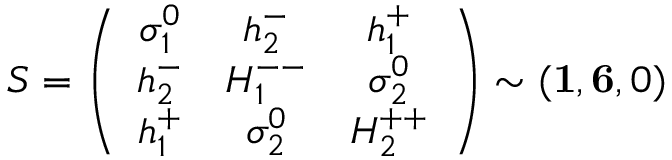<formula> <loc_0><loc_0><loc_500><loc_500>S = \left ( \begin{array} { c c c } { { \sigma _ { 1 } ^ { 0 } } } & { { h _ { 2 } ^ { - } } } & { { h _ { 1 } ^ { + } } } \\ { { h _ { 2 } ^ { - } } } & { { H _ { 1 } ^ { - - } } } & { { \sigma _ { 2 } ^ { 0 } } } \\ { { h _ { 1 } ^ { + } } } & { { \sigma _ { 2 } ^ { 0 } } } & { { H _ { 2 } ^ { + + } } } \end{array} \right ) \sim ( { 1 } , { 6 } , 0 )</formula> 